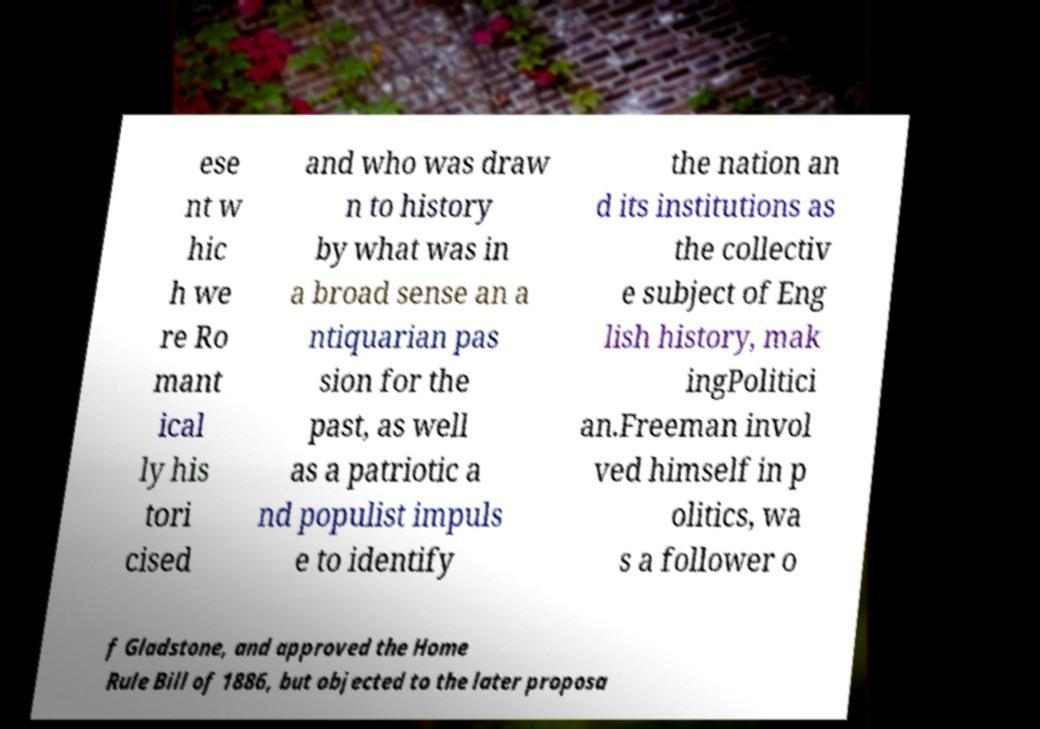Could you assist in decoding the text presented in this image and type it out clearly? ese nt w hic h we re Ro mant ical ly his tori cised and who was draw n to history by what was in a broad sense an a ntiquarian pas sion for the past, as well as a patriotic a nd populist impuls e to identify the nation an d its institutions as the collectiv e subject of Eng lish history, mak ingPolitici an.Freeman invol ved himself in p olitics, wa s a follower o f Gladstone, and approved the Home Rule Bill of 1886, but objected to the later proposa 